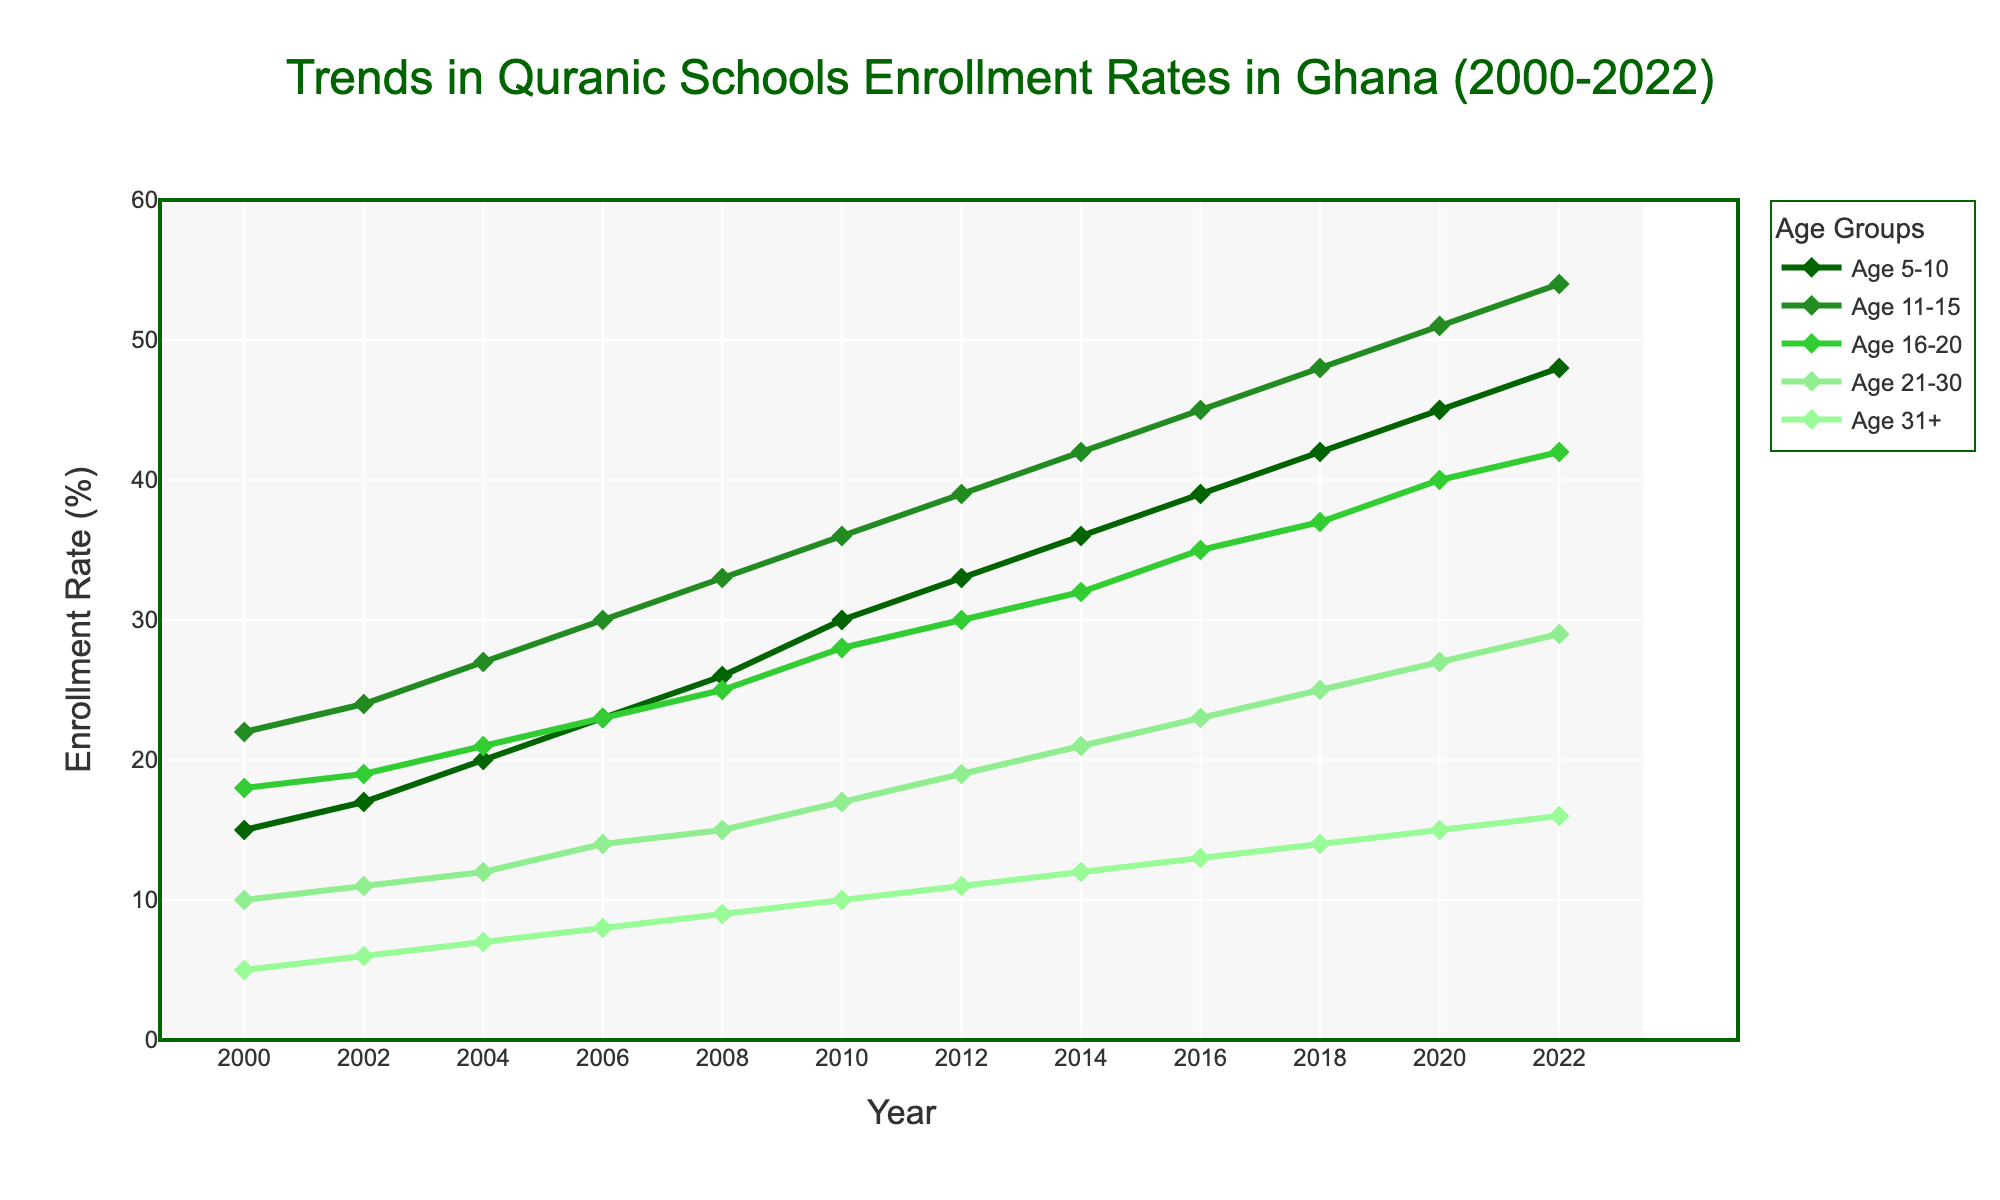What age group had the highest enrollment rate in 2022? Look at the enrollment rates for each age group in 2022. The age group with 54% has the highest rate.
Answer: Age 11-15 By how many percentage points did enrollment for ages 5-10 increase from 2000 to 2022? Calculate the difference between the enrollment rates for ages 5-10 in 2022 and 2000: 48% - 15% = 33%.
Answer: 33 Which age group had a steady increase in enrollment rates without any decline from 2000 to 2022? Observe the trends of enrollment rates for each age group from 2000 to 2022. The age group that consistently increases at each interval without any declines is the group.
Answer: Age 5-10 Compare the enrollment rates for ages 16-20 and 21-30 in 2018. Which was higher and by how much? Check the rates for ages 16-20 and 21-30 in 2018: 37% - 25% = 12%. Age 16-20 had the higher rate by 12%.
Answer: Age 16-20 by 12 What was the total enrollment rate for all age groups in the year 2004? Sum the enrollment rates for all age groups in 2004: 20 + 27 + 21 + 12 + 7 = 87%.
Answer: 87 Between which consecutive years did the age group 31+ see the largest increase in enrollment rate? Look for the largest difference in enrollment rates for age 31+ between consecutive years. The largest increase is between 2000 (5%) and 2002 (6%) seeing 1%.
Answer: 2000-2002 Estimate the average enrollment rate for the age group 21-30 over the years 2000 to 2022. Sum the enrollment rates for each year for the age group 21-30 and divide by the number of years: (10 + 11 + 12 + 14 + 15 + 17 + 19 + 21 + 23 + 25 + 27 + 29)/12 = 19.
Answer: 19 Which age group showed the least overall increase in enrollment rate from 2000 to 2022? Calculate the difference between 2022 and 2000 for each age group and identify the smallest increase: 16 - 5 = 11% for age 31+, which is the least.
Answer: Age 31+ Did the enrollment rate for ages 11-15 exceed 50% at any point in time? If so, in which year? Check the enrollment rates for ages 11-15 over the years to see if it ever exceeded 50%. The rate exceeded 50% in 2020 (51%) and 2022 (54%).
Answer: 2020, 2022 